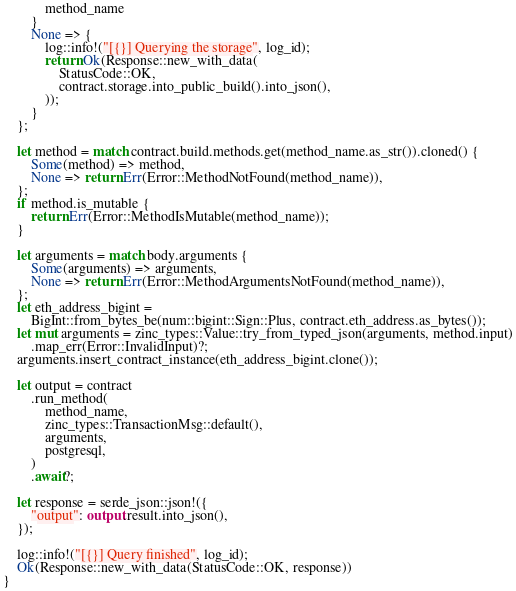Convert code to text. <code><loc_0><loc_0><loc_500><loc_500><_Rust_>            method_name
        }
        None => {
            log::info!("[{}] Querying the storage", log_id);
            return Ok(Response::new_with_data(
                StatusCode::OK,
                contract.storage.into_public_build().into_json(),
            ));
        }
    };

    let method = match contract.build.methods.get(method_name.as_str()).cloned() {
        Some(method) => method,
        None => return Err(Error::MethodNotFound(method_name)),
    };
    if method.is_mutable {
        return Err(Error::MethodIsMutable(method_name));
    }

    let arguments = match body.arguments {
        Some(arguments) => arguments,
        None => return Err(Error::MethodArgumentsNotFound(method_name)),
    };
    let eth_address_bigint =
        BigInt::from_bytes_be(num::bigint::Sign::Plus, contract.eth_address.as_bytes());
    let mut arguments = zinc_types::Value::try_from_typed_json(arguments, method.input)
        .map_err(Error::InvalidInput)?;
    arguments.insert_contract_instance(eth_address_bigint.clone());

    let output = contract
        .run_method(
            method_name,
            zinc_types::TransactionMsg::default(),
            arguments,
            postgresql,
        )
        .await?;

    let response = serde_json::json!({
        "output": output.result.into_json(),
    });

    log::info!("[{}] Query finished", log_id);
    Ok(Response::new_with_data(StatusCode::OK, response))
}
</code> 